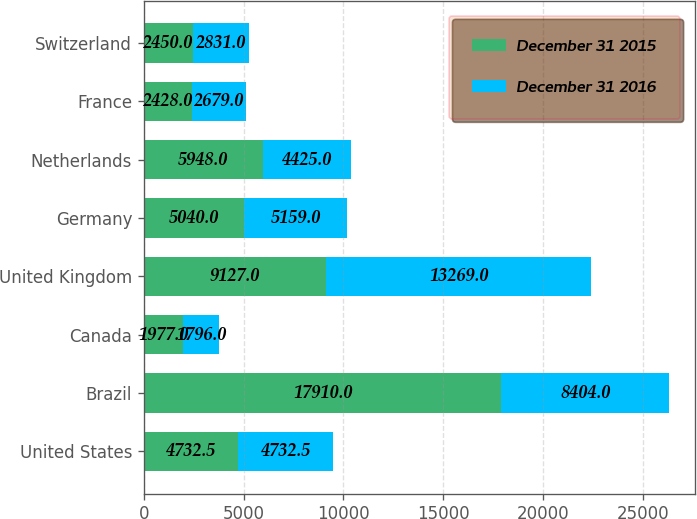Convert chart. <chart><loc_0><loc_0><loc_500><loc_500><stacked_bar_chart><ecel><fcel>United States<fcel>Brazil<fcel>Canada<fcel>United Kingdom<fcel>Germany<fcel>Netherlands<fcel>France<fcel>Switzerland<nl><fcel>December 31 2015<fcel>4732.5<fcel>17910<fcel>1977<fcel>9127<fcel>5040<fcel>5948<fcel>2428<fcel>2450<nl><fcel>December 31 2016<fcel>4732.5<fcel>8404<fcel>1796<fcel>13269<fcel>5159<fcel>4425<fcel>2679<fcel>2831<nl></chart> 